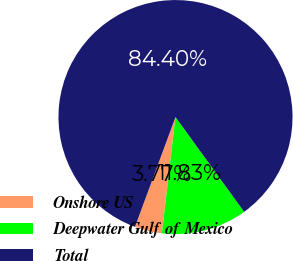<chart> <loc_0><loc_0><loc_500><loc_500><pie_chart><fcel>Onshore US<fcel>Deepwater Gulf of Mexico<fcel>Total<nl><fcel>3.77%<fcel>11.83%<fcel>84.4%<nl></chart> 